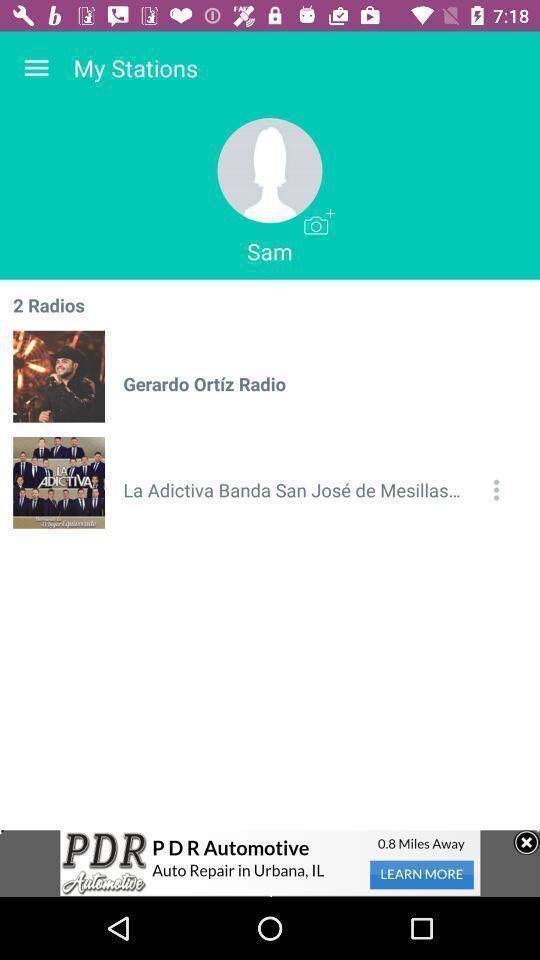Give me a summary of this screen capture. Page shows a contact in an music application. 